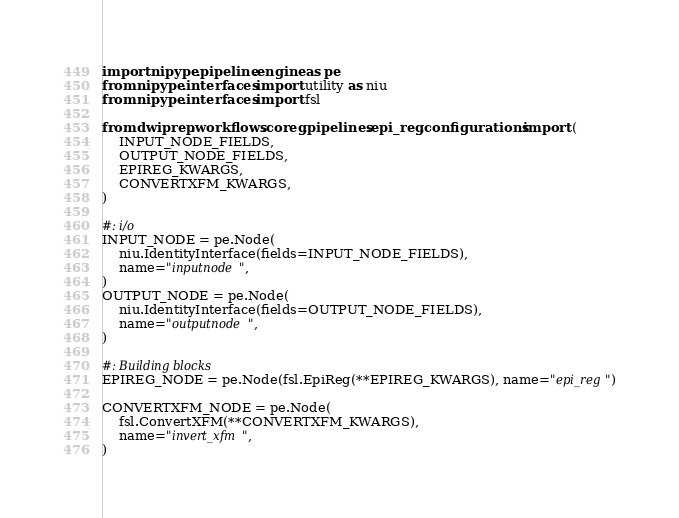Convert code to text. <code><loc_0><loc_0><loc_500><loc_500><_Python_>import nipype.pipeline.engine as pe
from nipype.interfaces import utility as niu
from nipype.interfaces import fsl

from dwiprep.workflows.coreg.pipelines.epi_reg.configurations import (
    INPUT_NODE_FIELDS,
    OUTPUT_NODE_FIELDS,
    EPIREG_KWARGS,
    CONVERTXFM_KWARGS,
)

#: i/o
INPUT_NODE = pe.Node(
    niu.IdentityInterface(fields=INPUT_NODE_FIELDS),
    name="inputnode",
)
OUTPUT_NODE = pe.Node(
    niu.IdentityInterface(fields=OUTPUT_NODE_FIELDS),
    name="outputnode",
)

#: Building blocks
EPIREG_NODE = pe.Node(fsl.EpiReg(**EPIREG_KWARGS), name="epi_reg")

CONVERTXFM_NODE = pe.Node(
    fsl.ConvertXFM(**CONVERTXFM_KWARGS),
    name="invert_xfm",
)
</code> 